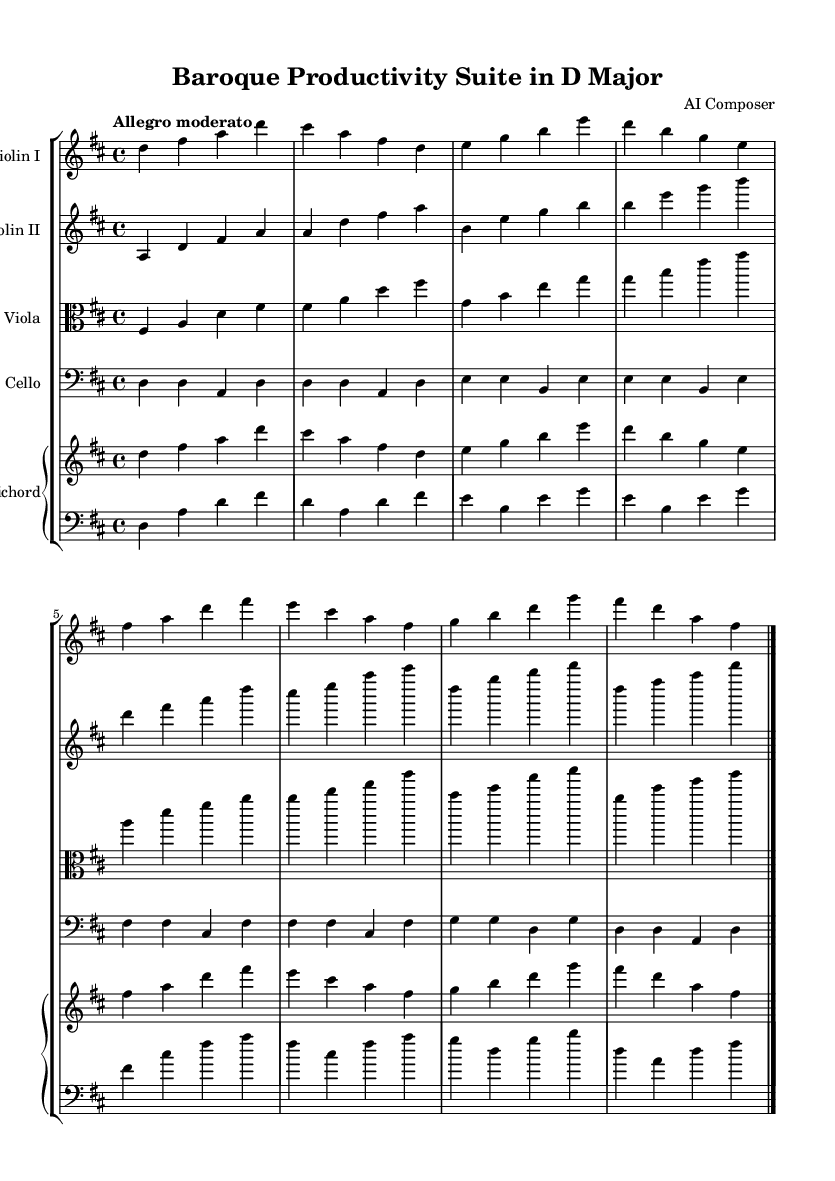What is the key signature of this music? The key signature is indicated at the beginning of the sheet music. It shows two sharps (F# and C#), which is characteristic of D major.
Answer: D major What is the time signature of this piece? The time signature is found at the beginning of the score, indicated as 4/4, meaning there are four beats in each measure and the quarter note gets one beat.
Answer: 4/4 What is the tempo marking of the piece? The tempo marking is shown above the staff and reads "Allegro moderato," suggesting a moderately fast tempo.
Answer: Allegro moderato How many instruments are specified in this score? The score explicitly groups the instruments as shown in the layout; there are four string instruments (two violins, one viola, and one cello) and a piano (harpsichord).
Answer: Five What is the relationship between the Violin I and the Violin II parts? Violin I plays the melody while Violin II typically supports with harmony or counter-melody, which is observed by comparing the note selections and rhythm patterns.
Answer: Melody and harmony How would the piece typically be performed in terms of dynamics? While dynamics are not explicitly given in the provided code, they would generally follow the conventions of Baroque music, indicating that performers should use expressive dynamics especially in the solo parts.
Answer: Expressively What role does the harpsichord play in this score? The harpsichord functions as the continuo instrument, providing harmonic support and rhythmic structure, typical of the Baroque style.
Answer: Continuo 